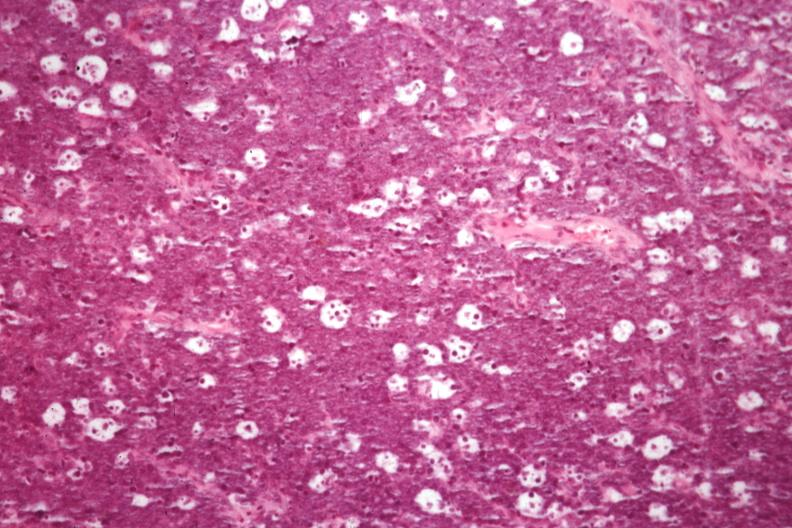s lymph node present?
Answer the question using a single word or phrase. Yes 